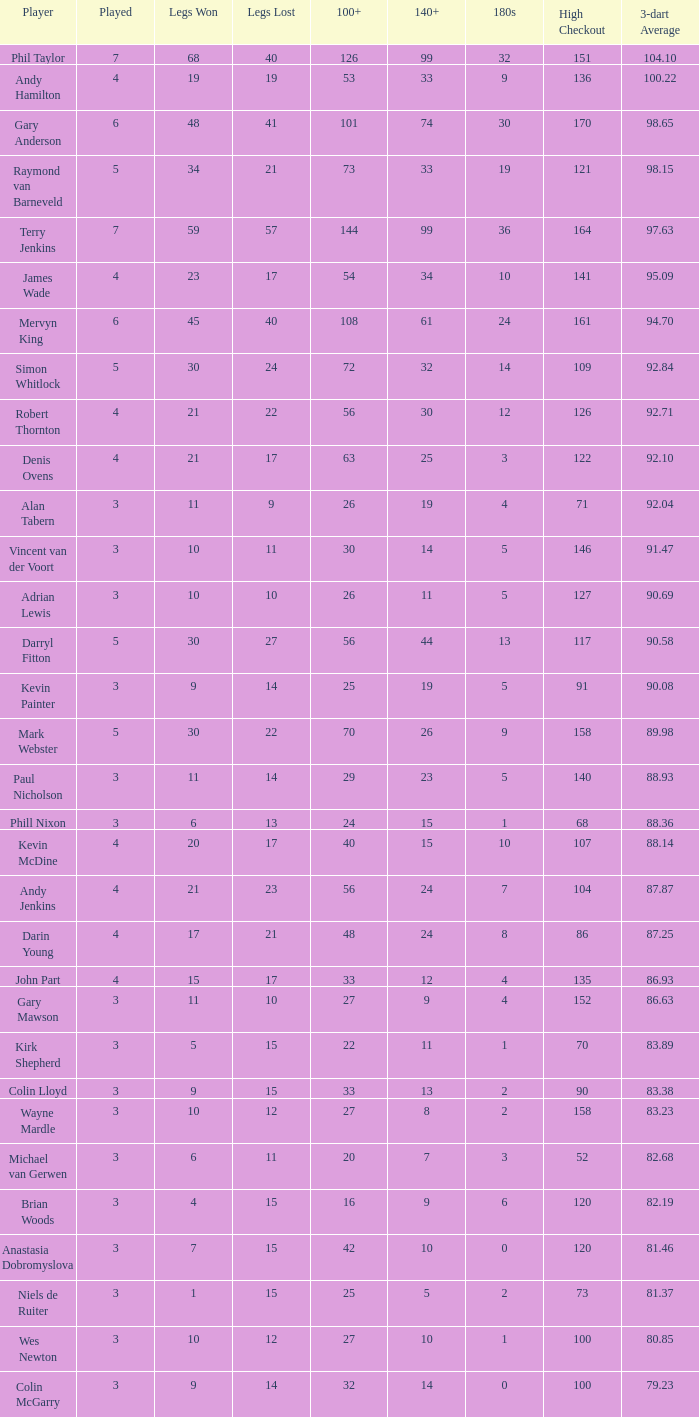When the high checkout is 135, what is the number played? 4.0. 